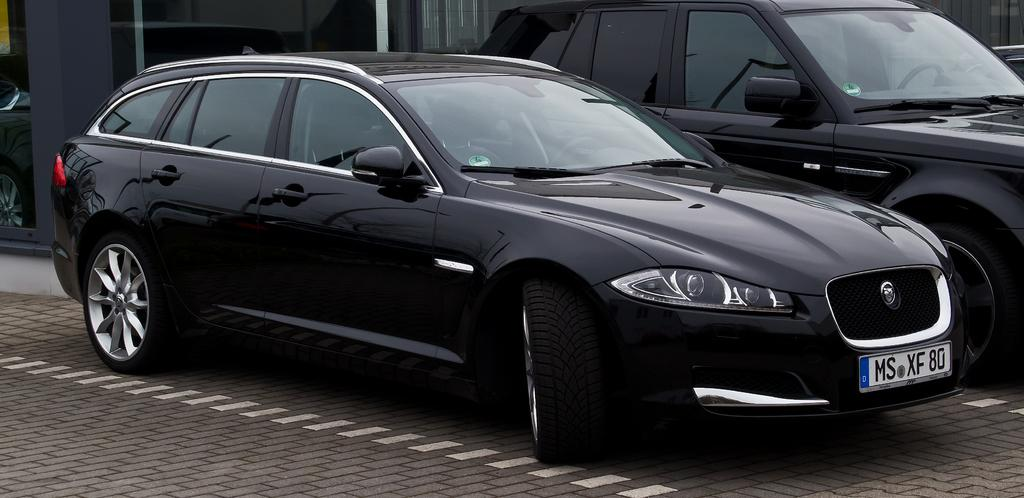What objects are on the floor in the image? There are two cars on the floor in the image. What can be seen behind the cars in the image? There is a background visible in the image, which includes glass and some objects. How does the rain affect the cars in the image? There is no rain present in the image, so its effect on the cars cannot be determined. 